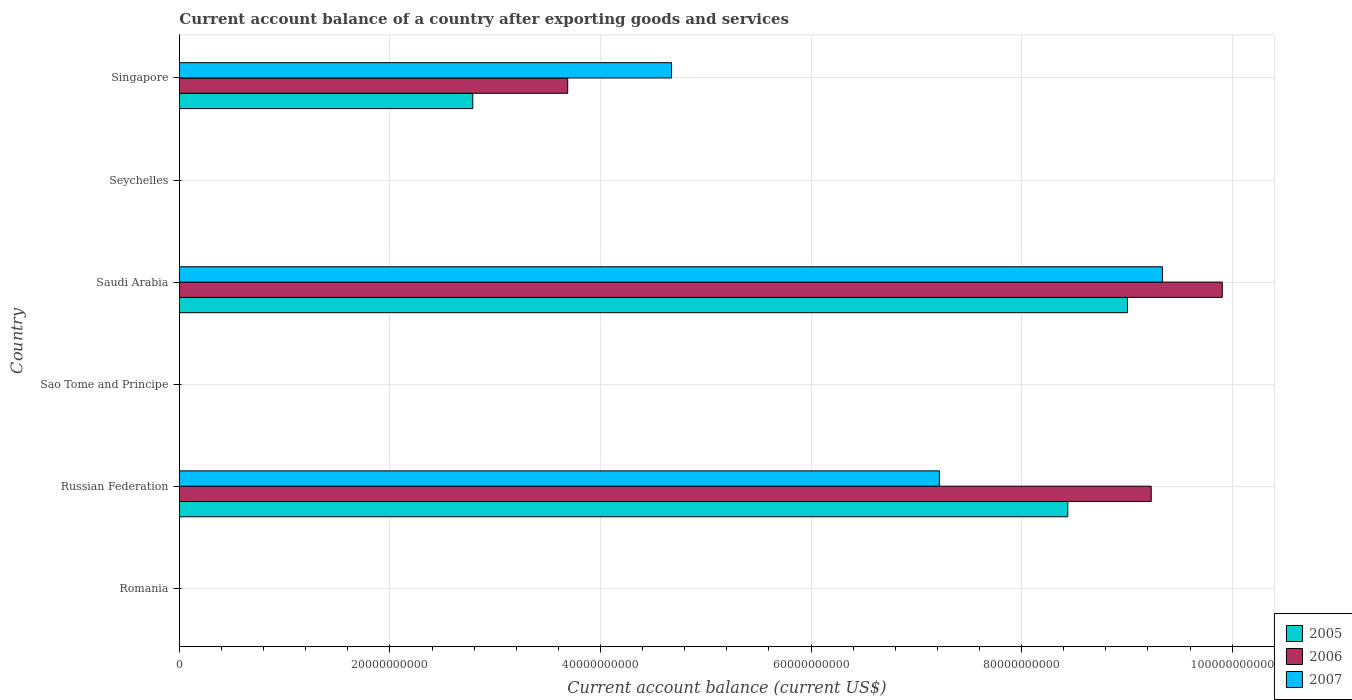Are the number of bars per tick equal to the number of legend labels?
Provide a short and direct response. No. What is the label of the 5th group of bars from the top?
Make the answer very short. Russian Federation. What is the account balance in 2006 in Sao Tome and Principe?
Your answer should be very brief. 0. Across all countries, what is the maximum account balance in 2005?
Your answer should be very brief. 9.01e+1. Across all countries, what is the minimum account balance in 2007?
Your answer should be very brief. 0. In which country was the account balance in 2007 maximum?
Your answer should be very brief. Saudi Arabia. What is the total account balance in 2005 in the graph?
Your answer should be compact. 2.02e+11. What is the difference between the account balance in 2005 in Russian Federation and that in Saudi Arabia?
Your answer should be very brief. -5.67e+09. What is the difference between the account balance in 2006 in Russian Federation and the account balance in 2005 in Singapore?
Ensure brevity in your answer.  6.44e+1. What is the average account balance in 2007 per country?
Give a very brief answer. 3.54e+1. What is the difference between the account balance in 2007 and account balance in 2006 in Singapore?
Offer a terse response. 9.86e+09. Is the difference between the account balance in 2007 in Russian Federation and Singapore greater than the difference between the account balance in 2006 in Russian Federation and Singapore?
Give a very brief answer. No. What is the difference between the highest and the second highest account balance in 2006?
Your answer should be very brief. 6.75e+09. What is the difference between the highest and the lowest account balance in 2005?
Offer a terse response. 9.01e+1. Is it the case that in every country, the sum of the account balance in 2005 and account balance in 2006 is greater than the account balance in 2007?
Offer a very short reply. No. How many bars are there?
Your answer should be very brief. 9. How many countries are there in the graph?
Your response must be concise. 6. What is the difference between two consecutive major ticks on the X-axis?
Ensure brevity in your answer.  2.00e+1. Are the values on the major ticks of X-axis written in scientific E-notation?
Provide a short and direct response. No. Does the graph contain any zero values?
Give a very brief answer. Yes. What is the title of the graph?
Offer a terse response. Current account balance of a country after exporting goods and services. What is the label or title of the X-axis?
Offer a terse response. Current account balance (current US$). What is the label or title of the Y-axis?
Your answer should be compact. Country. What is the Current account balance (current US$) in 2005 in Russian Federation?
Make the answer very short. 8.44e+1. What is the Current account balance (current US$) of 2006 in Russian Federation?
Keep it short and to the point. 9.23e+1. What is the Current account balance (current US$) in 2007 in Russian Federation?
Provide a succinct answer. 7.22e+1. What is the Current account balance (current US$) in 2005 in Saudi Arabia?
Your answer should be compact. 9.01e+1. What is the Current account balance (current US$) in 2006 in Saudi Arabia?
Ensure brevity in your answer.  9.91e+1. What is the Current account balance (current US$) in 2007 in Saudi Arabia?
Make the answer very short. 9.34e+1. What is the Current account balance (current US$) in 2005 in Seychelles?
Make the answer very short. 0. What is the Current account balance (current US$) in 2005 in Singapore?
Offer a very short reply. 2.79e+1. What is the Current account balance (current US$) in 2006 in Singapore?
Ensure brevity in your answer.  3.69e+1. What is the Current account balance (current US$) in 2007 in Singapore?
Your answer should be very brief. 4.67e+1. Across all countries, what is the maximum Current account balance (current US$) of 2005?
Make the answer very short. 9.01e+1. Across all countries, what is the maximum Current account balance (current US$) of 2006?
Ensure brevity in your answer.  9.91e+1. Across all countries, what is the maximum Current account balance (current US$) of 2007?
Offer a terse response. 9.34e+1. Across all countries, what is the minimum Current account balance (current US$) in 2006?
Your answer should be very brief. 0. Across all countries, what is the minimum Current account balance (current US$) in 2007?
Provide a succinct answer. 0. What is the total Current account balance (current US$) in 2005 in the graph?
Your response must be concise. 2.02e+11. What is the total Current account balance (current US$) in 2006 in the graph?
Give a very brief answer. 2.28e+11. What is the total Current account balance (current US$) in 2007 in the graph?
Your answer should be very brief. 2.12e+11. What is the difference between the Current account balance (current US$) of 2005 in Russian Federation and that in Saudi Arabia?
Offer a very short reply. -5.67e+09. What is the difference between the Current account balance (current US$) in 2006 in Russian Federation and that in Saudi Arabia?
Your answer should be very brief. -6.75e+09. What is the difference between the Current account balance (current US$) of 2007 in Russian Federation and that in Saudi Arabia?
Your answer should be compact. -2.12e+1. What is the difference between the Current account balance (current US$) of 2005 in Russian Federation and that in Singapore?
Make the answer very short. 5.65e+1. What is the difference between the Current account balance (current US$) of 2006 in Russian Federation and that in Singapore?
Your response must be concise. 5.54e+1. What is the difference between the Current account balance (current US$) in 2007 in Russian Federation and that in Singapore?
Provide a short and direct response. 2.54e+1. What is the difference between the Current account balance (current US$) of 2005 in Saudi Arabia and that in Singapore?
Ensure brevity in your answer.  6.22e+1. What is the difference between the Current account balance (current US$) of 2006 in Saudi Arabia and that in Singapore?
Provide a succinct answer. 6.22e+1. What is the difference between the Current account balance (current US$) of 2007 in Saudi Arabia and that in Singapore?
Provide a succinct answer. 4.66e+1. What is the difference between the Current account balance (current US$) of 2005 in Russian Federation and the Current account balance (current US$) of 2006 in Saudi Arabia?
Offer a very short reply. -1.47e+1. What is the difference between the Current account balance (current US$) of 2005 in Russian Federation and the Current account balance (current US$) of 2007 in Saudi Arabia?
Your answer should be very brief. -8.99e+09. What is the difference between the Current account balance (current US$) in 2006 in Russian Federation and the Current account balance (current US$) in 2007 in Saudi Arabia?
Provide a short and direct response. -1.06e+09. What is the difference between the Current account balance (current US$) of 2005 in Russian Federation and the Current account balance (current US$) of 2006 in Singapore?
Offer a terse response. 4.75e+1. What is the difference between the Current account balance (current US$) in 2005 in Russian Federation and the Current account balance (current US$) in 2007 in Singapore?
Your response must be concise. 3.76e+1. What is the difference between the Current account balance (current US$) of 2006 in Russian Federation and the Current account balance (current US$) of 2007 in Singapore?
Provide a succinct answer. 4.56e+1. What is the difference between the Current account balance (current US$) of 2005 in Saudi Arabia and the Current account balance (current US$) of 2006 in Singapore?
Make the answer very short. 5.32e+1. What is the difference between the Current account balance (current US$) in 2005 in Saudi Arabia and the Current account balance (current US$) in 2007 in Singapore?
Your answer should be compact. 4.33e+1. What is the difference between the Current account balance (current US$) in 2006 in Saudi Arabia and the Current account balance (current US$) in 2007 in Singapore?
Provide a short and direct response. 5.23e+1. What is the average Current account balance (current US$) of 2005 per country?
Ensure brevity in your answer.  3.37e+1. What is the average Current account balance (current US$) of 2006 per country?
Give a very brief answer. 3.80e+1. What is the average Current account balance (current US$) of 2007 per country?
Make the answer very short. 3.54e+1. What is the difference between the Current account balance (current US$) in 2005 and Current account balance (current US$) in 2006 in Russian Federation?
Your response must be concise. -7.93e+09. What is the difference between the Current account balance (current US$) of 2005 and Current account balance (current US$) of 2007 in Russian Federation?
Provide a succinct answer. 1.22e+1. What is the difference between the Current account balance (current US$) of 2006 and Current account balance (current US$) of 2007 in Russian Federation?
Offer a very short reply. 2.01e+1. What is the difference between the Current account balance (current US$) of 2005 and Current account balance (current US$) of 2006 in Saudi Arabia?
Your answer should be compact. -9.01e+09. What is the difference between the Current account balance (current US$) of 2005 and Current account balance (current US$) of 2007 in Saudi Arabia?
Offer a terse response. -3.32e+09. What is the difference between the Current account balance (current US$) in 2006 and Current account balance (current US$) in 2007 in Saudi Arabia?
Offer a terse response. 5.69e+09. What is the difference between the Current account balance (current US$) in 2005 and Current account balance (current US$) in 2006 in Singapore?
Offer a terse response. -9.02e+09. What is the difference between the Current account balance (current US$) in 2005 and Current account balance (current US$) in 2007 in Singapore?
Your answer should be compact. -1.89e+1. What is the difference between the Current account balance (current US$) in 2006 and Current account balance (current US$) in 2007 in Singapore?
Make the answer very short. -9.86e+09. What is the ratio of the Current account balance (current US$) in 2005 in Russian Federation to that in Saudi Arabia?
Your answer should be very brief. 0.94. What is the ratio of the Current account balance (current US$) of 2006 in Russian Federation to that in Saudi Arabia?
Offer a terse response. 0.93. What is the ratio of the Current account balance (current US$) of 2007 in Russian Federation to that in Saudi Arabia?
Your answer should be very brief. 0.77. What is the ratio of the Current account balance (current US$) of 2005 in Russian Federation to that in Singapore?
Offer a terse response. 3.03. What is the ratio of the Current account balance (current US$) of 2006 in Russian Federation to that in Singapore?
Provide a succinct answer. 2.5. What is the ratio of the Current account balance (current US$) of 2007 in Russian Federation to that in Singapore?
Your answer should be very brief. 1.54. What is the ratio of the Current account balance (current US$) of 2005 in Saudi Arabia to that in Singapore?
Your answer should be compact. 3.23. What is the ratio of the Current account balance (current US$) in 2006 in Saudi Arabia to that in Singapore?
Your answer should be very brief. 2.69. What is the ratio of the Current account balance (current US$) of 2007 in Saudi Arabia to that in Singapore?
Your answer should be very brief. 2. What is the difference between the highest and the second highest Current account balance (current US$) of 2005?
Give a very brief answer. 5.67e+09. What is the difference between the highest and the second highest Current account balance (current US$) in 2006?
Offer a very short reply. 6.75e+09. What is the difference between the highest and the second highest Current account balance (current US$) in 2007?
Your answer should be very brief. 2.12e+1. What is the difference between the highest and the lowest Current account balance (current US$) in 2005?
Make the answer very short. 9.01e+1. What is the difference between the highest and the lowest Current account balance (current US$) of 2006?
Give a very brief answer. 9.91e+1. What is the difference between the highest and the lowest Current account balance (current US$) in 2007?
Make the answer very short. 9.34e+1. 